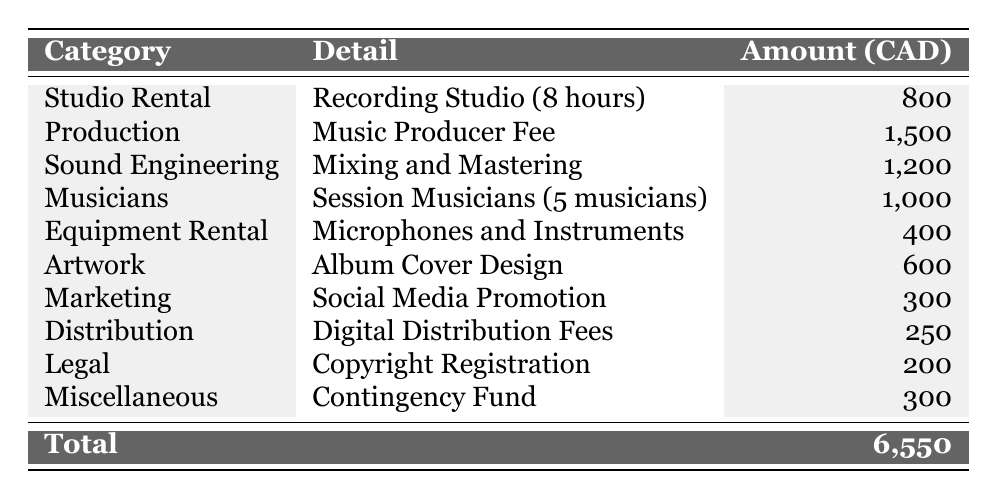What is the total amount spent on producing the music album? The total amount can be found in the last row of the table, which states the total is 6,550 CAD.
Answer: 6,550 CAD How much was spent on sound engineering? The amount spent on sound engineering is specified in the table under the Sound Engineering category as 1,200 CAD.
Answer: 1,200 CAD What is the cost of the artwork for the album? The cost of artwork is indicated in the table as 600 CAD under the Artwork category.
Answer: 600 CAD Which category has the highest expense? By comparing all the amounts listed in the table, the highest expense is found in the Production category with a fee of 1,500 CAD.
Answer: Production What is the total amount spent on marketing and legal fees combined? The marketing expense is 300 CAD and the legal fee is 200 CAD. Adding these together gives 300 + 200 = 500 CAD.
Answer: 500 CAD Is the cost of studio rental more than the equipment rental cost? The studio rental cost is 800 CAD, while the equipment rental cost is 400 CAD. Since 800 is greater than 400, the statement is true.
Answer: Yes What percentage of the total expense is attributed to session musicians? The cost for session musicians is 1,000 CAD and the total expense is 6,550 CAD. The percentage is calculated as (1,000 / 6,550) * 100, which results in approximately 15.26%.
Answer: 15.26% If we exclude the highest expense, what is the new total? The highest expense is the Production cost of 1,500 CAD. Excluding this from the total 6,550 CAD gives us 6,550 - 1,500 = 5,050 CAD.
Answer: 5,050 CAD How much more is spent on sound engineering than on equipment rental? The amount spent on sound engineering is 1,200 CAD and on equipment rental is 400 CAD. The difference is 1,200 - 400 = 800 CAD.
Answer: 800 CAD What is the average expense across all categories? The total expense is 6,550 CAD and there are 10 categories. The average is calculated as 6,550 / 10 = 655 CAD.
Answer: 655 CAD 